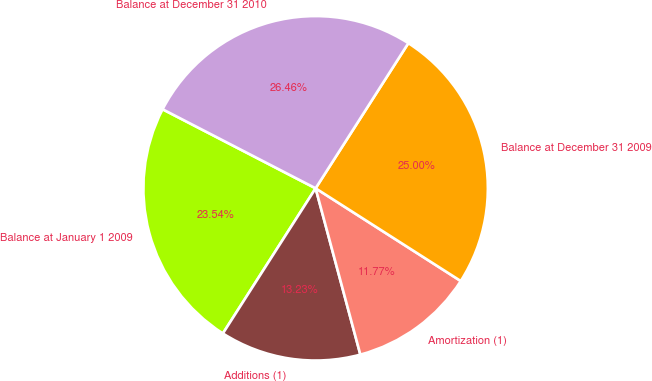Convert chart to OTSL. <chart><loc_0><loc_0><loc_500><loc_500><pie_chart><fcel>Balance at January 1 2009<fcel>Additions (1)<fcel>Amortization (1)<fcel>Balance at December 31 2009<fcel>Balance at December 31 2010<nl><fcel>23.54%<fcel>13.23%<fcel>11.77%<fcel>25.0%<fcel>26.46%<nl></chart> 